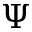Convert formula to latex. <formula><loc_0><loc_0><loc_500><loc_500>\Psi</formula> 